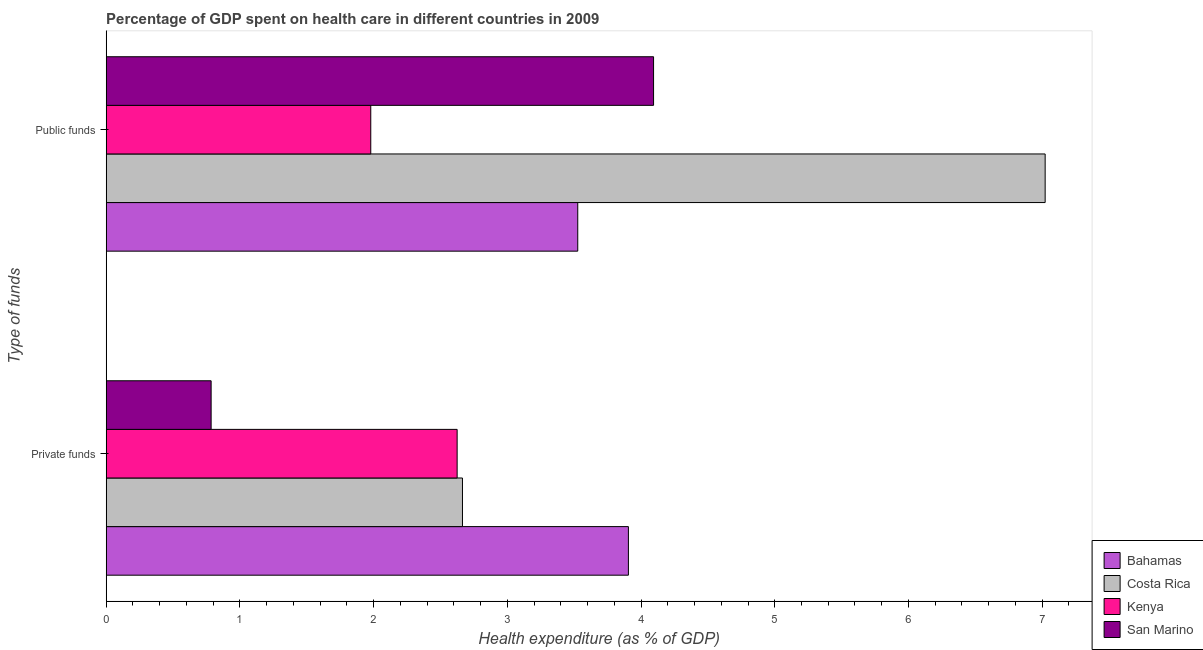How many different coloured bars are there?
Make the answer very short. 4. How many groups of bars are there?
Your answer should be compact. 2. How many bars are there on the 1st tick from the top?
Provide a succinct answer. 4. What is the label of the 2nd group of bars from the top?
Offer a very short reply. Private funds. What is the amount of public funds spent in healthcare in Bahamas?
Make the answer very short. 3.53. Across all countries, what is the maximum amount of public funds spent in healthcare?
Keep it short and to the point. 7.02. Across all countries, what is the minimum amount of private funds spent in healthcare?
Ensure brevity in your answer.  0.78. In which country was the amount of private funds spent in healthcare maximum?
Provide a succinct answer. Bahamas. In which country was the amount of private funds spent in healthcare minimum?
Give a very brief answer. San Marino. What is the total amount of public funds spent in healthcare in the graph?
Your answer should be very brief. 16.62. What is the difference between the amount of public funds spent in healthcare in Costa Rica and that in Kenya?
Your answer should be very brief. 5.04. What is the difference between the amount of public funds spent in healthcare in Costa Rica and the amount of private funds spent in healthcare in Kenya?
Ensure brevity in your answer.  4.4. What is the average amount of public funds spent in healthcare per country?
Provide a succinct answer. 4.16. What is the difference between the amount of public funds spent in healthcare and amount of private funds spent in healthcare in Bahamas?
Give a very brief answer. -0.38. What is the ratio of the amount of public funds spent in healthcare in Kenya to that in Bahamas?
Ensure brevity in your answer.  0.56. Is the amount of public funds spent in healthcare in Costa Rica less than that in Kenya?
Your answer should be compact. No. In how many countries, is the amount of private funds spent in healthcare greater than the average amount of private funds spent in healthcare taken over all countries?
Keep it short and to the point. 3. What does the 4th bar from the top in Private funds represents?
Offer a very short reply. Bahamas. What does the 1st bar from the bottom in Public funds represents?
Provide a short and direct response. Bahamas. Are all the bars in the graph horizontal?
Keep it short and to the point. Yes. How many countries are there in the graph?
Your answer should be very brief. 4. What is the difference between two consecutive major ticks on the X-axis?
Make the answer very short. 1. Does the graph contain grids?
Ensure brevity in your answer.  No. How are the legend labels stacked?
Provide a short and direct response. Vertical. What is the title of the graph?
Offer a very short reply. Percentage of GDP spent on health care in different countries in 2009. What is the label or title of the X-axis?
Your answer should be very brief. Health expenditure (as % of GDP). What is the label or title of the Y-axis?
Offer a terse response. Type of funds. What is the Health expenditure (as % of GDP) in Bahamas in Private funds?
Your response must be concise. 3.91. What is the Health expenditure (as % of GDP) of Costa Rica in Private funds?
Give a very brief answer. 2.66. What is the Health expenditure (as % of GDP) in Kenya in Private funds?
Offer a terse response. 2.62. What is the Health expenditure (as % of GDP) of San Marino in Private funds?
Keep it short and to the point. 0.78. What is the Health expenditure (as % of GDP) in Bahamas in Public funds?
Your answer should be very brief. 3.53. What is the Health expenditure (as % of GDP) in Costa Rica in Public funds?
Your answer should be compact. 7.02. What is the Health expenditure (as % of GDP) in Kenya in Public funds?
Provide a succinct answer. 1.98. What is the Health expenditure (as % of GDP) of San Marino in Public funds?
Offer a very short reply. 4.09. Across all Type of funds, what is the maximum Health expenditure (as % of GDP) of Bahamas?
Provide a succinct answer. 3.91. Across all Type of funds, what is the maximum Health expenditure (as % of GDP) of Costa Rica?
Offer a terse response. 7.02. Across all Type of funds, what is the maximum Health expenditure (as % of GDP) of Kenya?
Your answer should be very brief. 2.62. Across all Type of funds, what is the maximum Health expenditure (as % of GDP) of San Marino?
Your response must be concise. 4.09. Across all Type of funds, what is the minimum Health expenditure (as % of GDP) of Bahamas?
Your response must be concise. 3.53. Across all Type of funds, what is the minimum Health expenditure (as % of GDP) in Costa Rica?
Give a very brief answer. 2.66. Across all Type of funds, what is the minimum Health expenditure (as % of GDP) in Kenya?
Your answer should be very brief. 1.98. Across all Type of funds, what is the minimum Health expenditure (as % of GDP) of San Marino?
Keep it short and to the point. 0.78. What is the total Health expenditure (as % of GDP) of Bahamas in the graph?
Ensure brevity in your answer.  7.43. What is the total Health expenditure (as % of GDP) of Costa Rica in the graph?
Offer a terse response. 9.69. What is the total Health expenditure (as % of GDP) of Kenya in the graph?
Keep it short and to the point. 4.6. What is the total Health expenditure (as % of GDP) of San Marino in the graph?
Make the answer very short. 4.88. What is the difference between the Health expenditure (as % of GDP) in Bahamas in Private funds and that in Public funds?
Ensure brevity in your answer.  0.38. What is the difference between the Health expenditure (as % of GDP) of Costa Rica in Private funds and that in Public funds?
Your answer should be compact. -4.36. What is the difference between the Health expenditure (as % of GDP) of Kenya in Private funds and that in Public funds?
Provide a short and direct response. 0.65. What is the difference between the Health expenditure (as % of GDP) of San Marino in Private funds and that in Public funds?
Make the answer very short. -3.31. What is the difference between the Health expenditure (as % of GDP) of Bahamas in Private funds and the Health expenditure (as % of GDP) of Costa Rica in Public funds?
Provide a short and direct response. -3.12. What is the difference between the Health expenditure (as % of GDP) of Bahamas in Private funds and the Health expenditure (as % of GDP) of Kenya in Public funds?
Your response must be concise. 1.93. What is the difference between the Health expenditure (as % of GDP) in Bahamas in Private funds and the Health expenditure (as % of GDP) in San Marino in Public funds?
Your response must be concise. -0.19. What is the difference between the Health expenditure (as % of GDP) in Costa Rica in Private funds and the Health expenditure (as % of GDP) in Kenya in Public funds?
Your response must be concise. 0.69. What is the difference between the Health expenditure (as % of GDP) of Costa Rica in Private funds and the Health expenditure (as % of GDP) of San Marino in Public funds?
Your answer should be compact. -1.43. What is the difference between the Health expenditure (as % of GDP) of Kenya in Private funds and the Health expenditure (as % of GDP) of San Marino in Public funds?
Your response must be concise. -1.47. What is the average Health expenditure (as % of GDP) in Bahamas per Type of funds?
Provide a succinct answer. 3.72. What is the average Health expenditure (as % of GDP) of Costa Rica per Type of funds?
Give a very brief answer. 4.84. What is the average Health expenditure (as % of GDP) in Kenya per Type of funds?
Keep it short and to the point. 2.3. What is the average Health expenditure (as % of GDP) of San Marino per Type of funds?
Provide a succinct answer. 2.44. What is the difference between the Health expenditure (as % of GDP) of Bahamas and Health expenditure (as % of GDP) of Costa Rica in Private funds?
Your response must be concise. 1.24. What is the difference between the Health expenditure (as % of GDP) of Bahamas and Health expenditure (as % of GDP) of Kenya in Private funds?
Offer a very short reply. 1.28. What is the difference between the Health expenditure (as % of GDP) in Bahamas and Health expenditure (as % of GDP) in San Marino in Private funds?
Offer a very short reply. 3.12. What is the difference between the Health expenditure (as % of GDP) of Costa Rica and Health expenditure (as % of GDP) of Kenya in Private funds?
Keep it short and to the point. 0.04. What is the difference between the Health expenditure (as % of GDP) in Costa Rica and Health expenditure (as % of GDP) in San Marino in Private funds?
Your response must be concise. 1.88. What is the difference between the Health expenditure (as % of GDP) of Kenya and Health expenditure (as % of GDP) of San Marino in Private funds?
Offer a very short reply. 1.84. What is the difference between the Health expenditure (as % of GDP) of Bahamas and Health expenditure (as % of GDP) of Costa Rica in Public funds?
Provide a succinct answer. -3.5. What is the difference between the Health expenditure (as % of GDP) in Bahamas and Health expenditure (as % of GDP) in Kenya in Public funds?
Keep it short and to the point. 1.55. What is the difference between the Health expenditure (as % of GDP) of Bahamas and Health expenditure (as % of GDP) of San Marino in Public funds?
Your answer should be compact. -0.57. What is the difference between the Health expenditure (as % of GDP) in Costa Rica and Health expenditure (as % of GDP) in Kenya in Public funds?
Offer a terse response. 5.04. What is the difference between the Health expenditure (as % of GDP) in Costa Rica and Health expenditure (as % of GDP) in San Marino in Public funds?
Your answer should be compact. 2.93. What is the difference between the Health expenditure (as % of GDP) in Kenya and Health expenditure (as % of GDP) in San Marino in Public funds?
Your answer should be compact. -2.12. What is the ratio of the Health expenditure (as % of GDP) of Bahamas in Private funds to that in Public funds?
Provide a short and direct response. 1.11. What is the ratio of the Health expenditure (as % of GDP) of Costa Rica in Private funds to that in Public funds?
Provide a short and direct response. 0.38. What is the ratio of the Health expenditure (as % of GDP) of Kenya in Private funds to that in Public funds?
Keep it short and to the point. 1.33. What is the ratio of the Health expenditure (as % of GDP) of San Marino in Private funds to that in Public funds?
Offer a terse response. 0.19. What is the difference between the highest and the second highest Health expenditure (as % of GDP) in Bahamas?
Your answer should be very brief. 0.38. What is the difference between the highest and the second highest Health expenditure (as % of GDP) of Costa Rica?
Provide a succinct answer. 4.36. What is the difference between the highest and the second highest Health expenditure (as % of GDP) of Kenya?
Your answer should be very brief. 0.65. What is the difference between the highest and the second highest Health expenditure (as % of GDP) of San Marino?
Your answer should be very brief. 3.31. What is the difference between the highest and the lowest Health expenditure (as % of GDP) of Bahamas?
Make the answer very short. 0.38. What is the difference between the highest and the lowest Health expenditure (as % of GDP) in Costa Rica?
Provide a short and direct response. 4.36. What is the difference between the highest and the lowest Health expenditure (as % of GDP) of Kenya?
Offer a terse response. 0.65. What is the difference between the highest and the lowest Health expenditure (as % of GDP) in San Marino?
Make the answer very short. 3.31. 